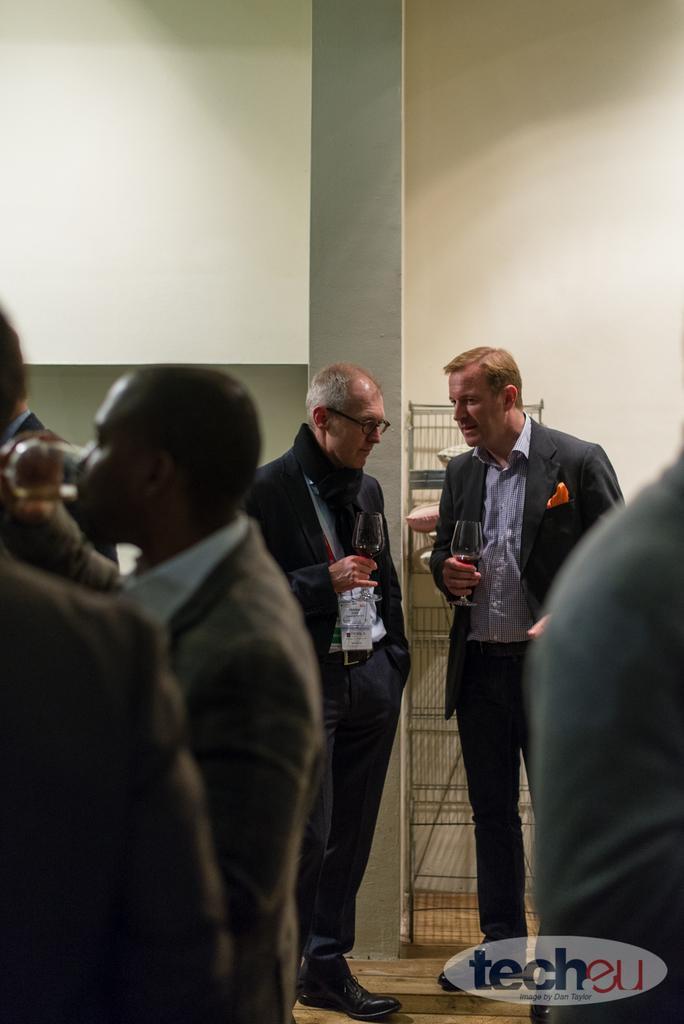Can you describe this image briefly? This is the picture of a room. In the foreground there is a person standing and holding the glass and there are three persons standing. At the back there are two persons standing and holding glasses. At the back there is a stand and there is a wall. In the bottom right there is a text. 